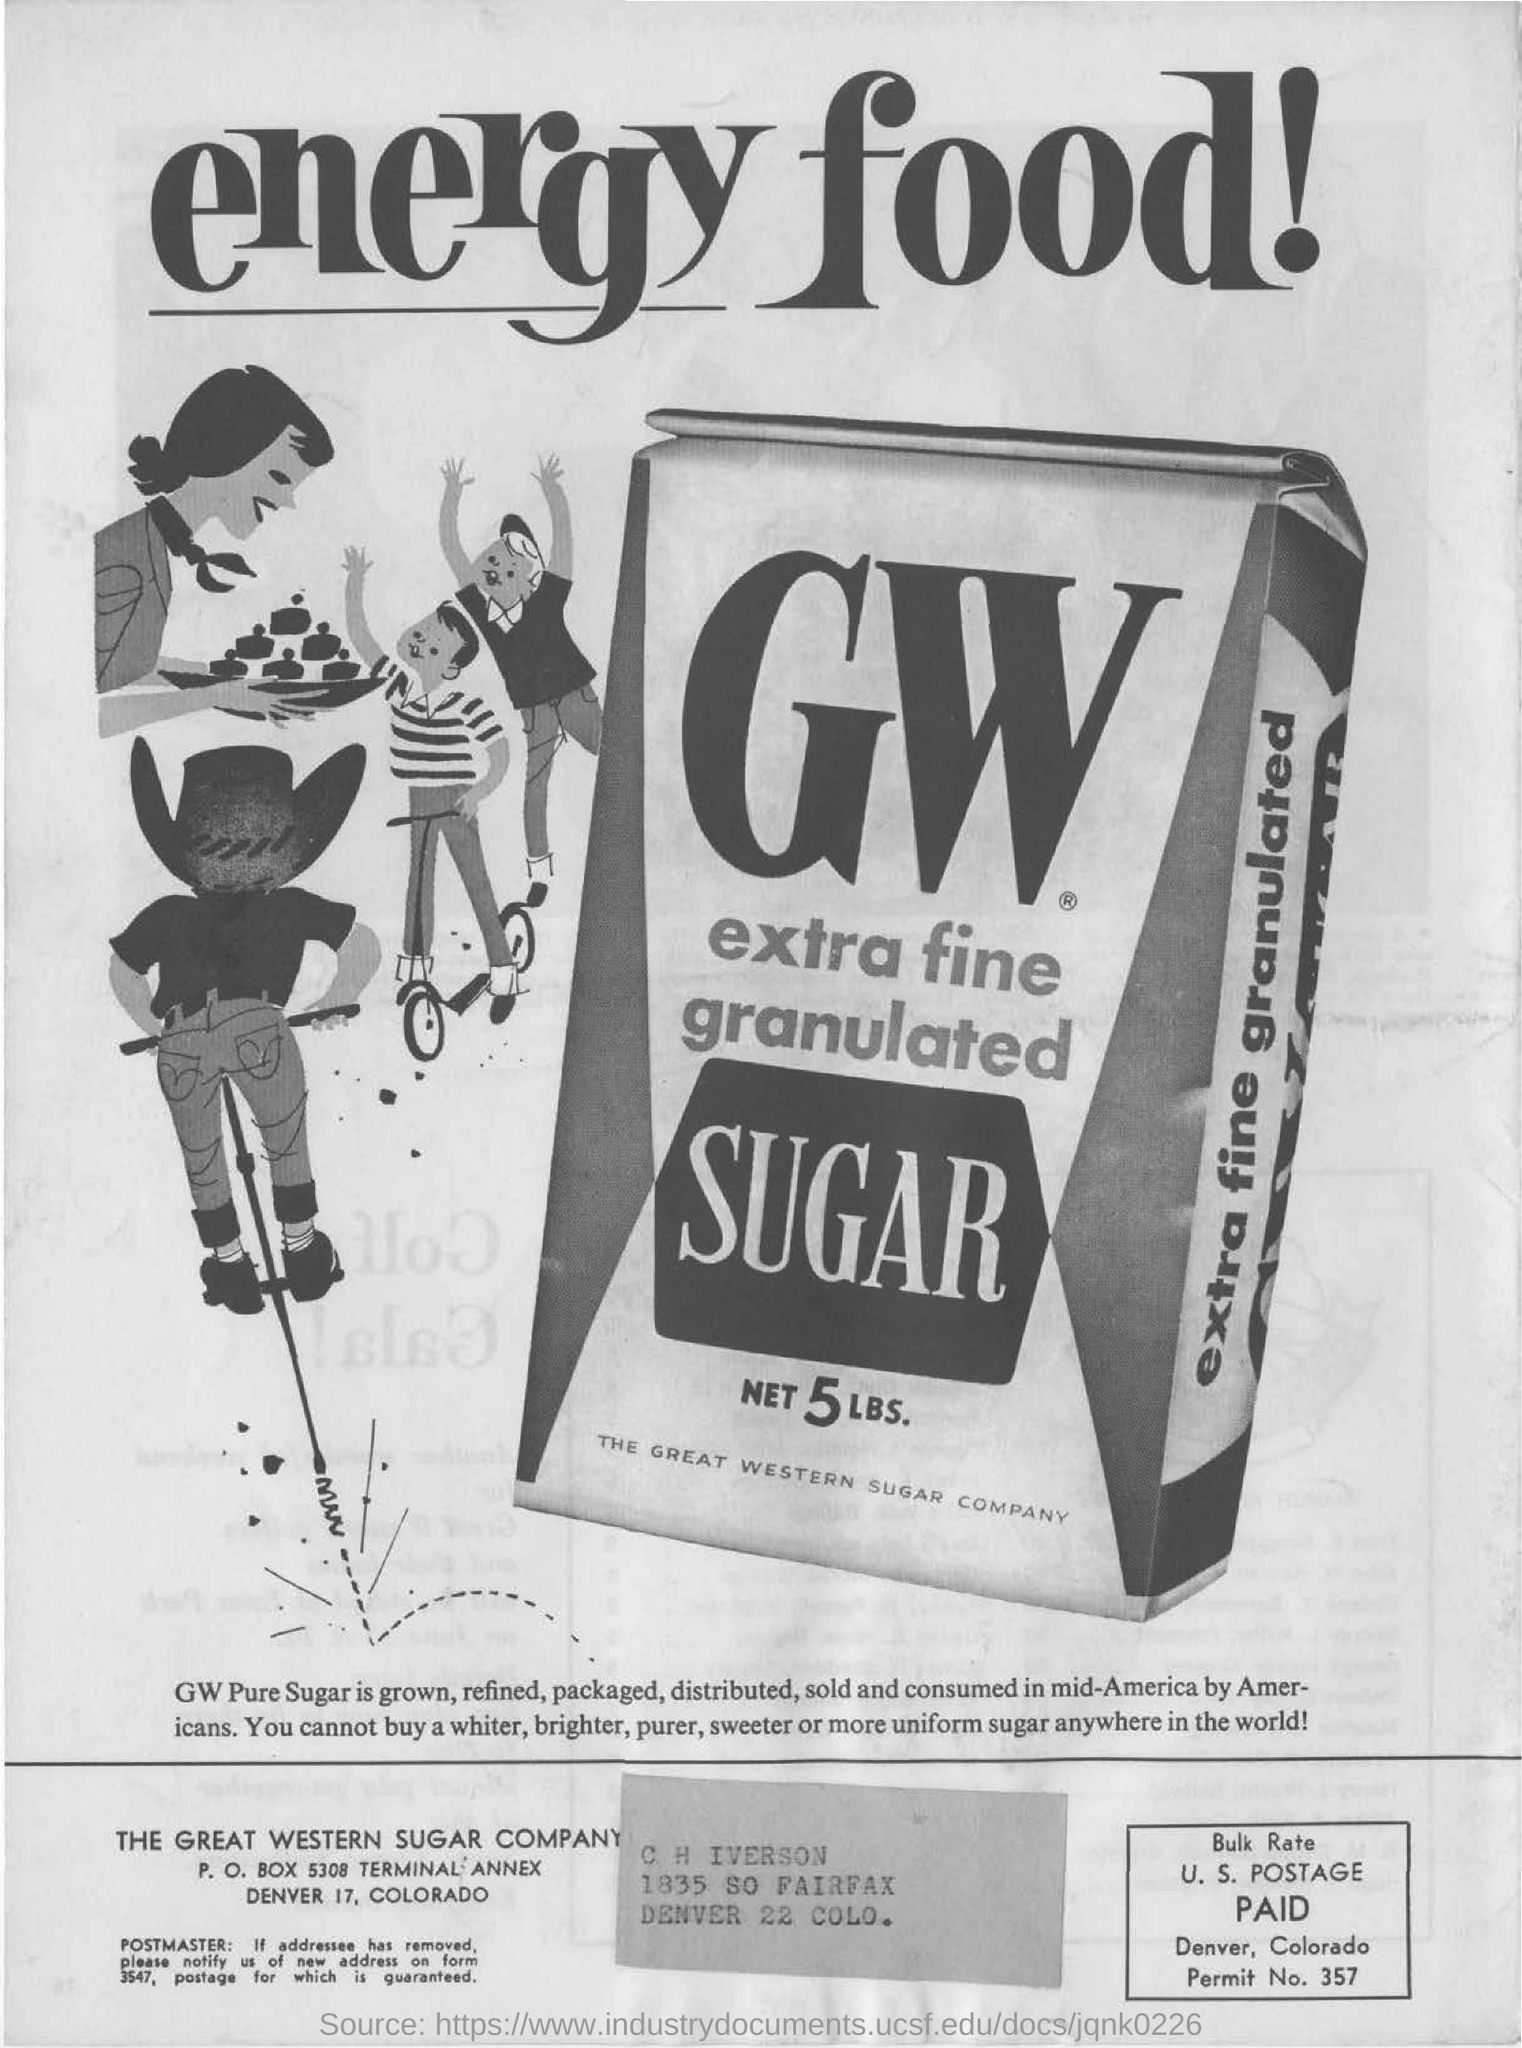What is the title on top?
Make the answer very short. ENERGY FOOD!. What is the image advertising?
Offer a terse response. GW EXTRA FINE GRANULATED SUGAR. What is the net amount of the sugar?
Ensure brevity in your answer.  5 lbs. 